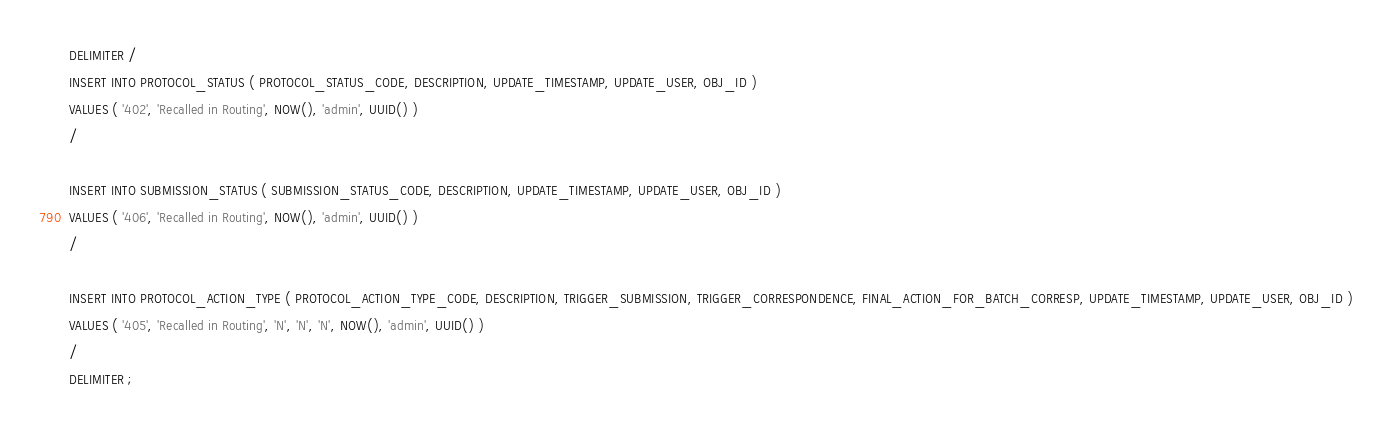<code> <loc_0><loc_0><loc_500><loc_500><_SQL_>DELIMITER /
INSERT INTO PROTOCOL_STATUS ( PROTOCOL_STATUS_CODE, DESCRIPTION, UPDATE_TIMESTAMP, UPDATE_USER, OBJ_ID ) 
VALUES ( '402', 'Recalled in Routing', NOW(), 'admin', UUID() ) 
/

INSERT INTO SUBMISSION_STATUS ( SUBMISSION_STATUS_CODE, DESCRIPTION, UPDATE_TIMESTAMP, UPDATE_USER, OBJ_ID ) 
VALUES ( '406', 'Recalled in Routing', NOW(), 'admin', UUID() ) 
/

INSERT INTO PROTOCOL_ACTION_TYPE ( PROTOCOL_ACTION_TYPE_CODE, DESCRIPTION, TRIGGER_SUBMISSION, TRIGGER_CORRESPONDENCE, FINAL_ACTION_FOR_BATCH_CORRESP, UPDATE_TIMESTAMP, UPDATE_USER, OBJ_ID ) 
VALUES ( '405', 'Recalled in Routing', 'N', 'N', 'N', NOW(), 'admin', UUID() ) 
/
DELIMITER ;
</code> 